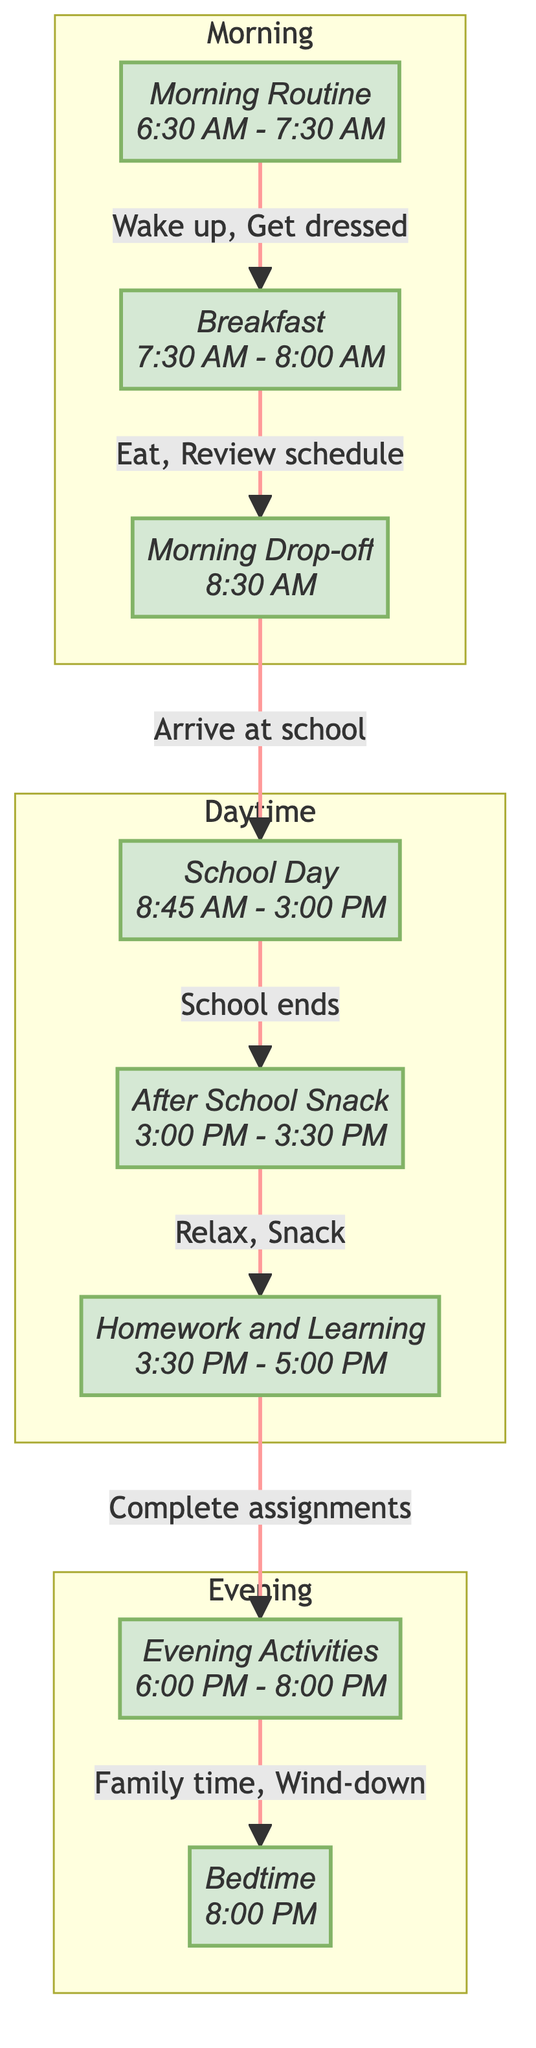What is the time for Breakfast in the diagram? The diagram specifies "Breakfast" as taking place from "7:30 AM" to "8:00 AM". This is found directly under the Breakfast node.
Answer: 7:30 AM - 8:00 AM How many activities are listed under Evening Activities? The Evening Activities node lists a total of five activities: "Eat dinner," "Family time," "Calm play," "Prepare school bag for next day," and "Gentle wind-down such as light reading or drawing." This count can be confirmed by reading each activity listed in that node.
Answer: 5 What activity occurs directly after the After School Snack? Following the After School Snack node, the next node is Homework and Learning. This is indicated by the arrow connecting AS to HL.
Answer: Complete school assignments What is the main transition between the School Day and Evening Activities? The transition from School Day to Evening Activities is marked by the completion of the School Day which is then linked to the After School Snack, followed by Homework and Learning before moving to Evening Activities. The flow is outlined through the nodes and connections.
Answer: After School Snack List the last activity performed during Bedtime. The last activity listed under Bedtime is "Turn off lights and say goodnight." This is the final activity indicated in the Bedtime node.
Answer: Turn off lights and say goodnight What time range does Homework and Learning occur? The Homework and Learning node specifies the time range as "3:30 PM - 5:00 PM." This information is directly shown within that node in the diagram.
Answer: 3:30 PM - 5:00 PM Which part of the day does the Morning Routine belong to? The Morning Routine is included in the "Morning" subgraph, which is shown separately at the top of the diagram and contains the nodes for the morning activities.
Answer: Morning How do the Evening Activities relate to Bedtime? The Evening Activities occur directly before Bedtime; specifically, they end at 8:00 PM, at which point the Bedtime routine begins. This relationship is depicted in the flow leading from EA to BT.
Answer: Directly before 